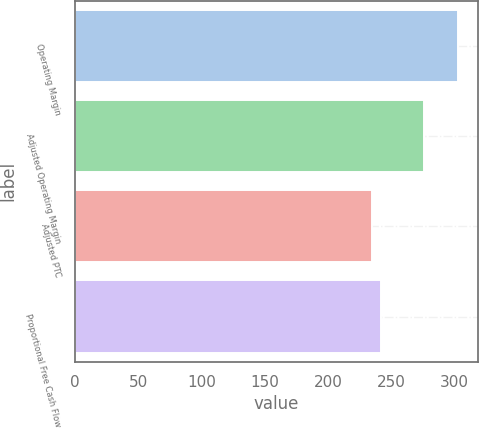Convert chart. <chart><loc_0><loc_0><loc_500><loc_500><bar_chart><fcel>Operating Margin<fcel>Adjusted Operating Margin<fcel>Adjusted PTC<fcel>Proportional Free Cash Flow<nl><fcel>303<fcel>276<fcel>235<fcel>241.8<nl></chart> 